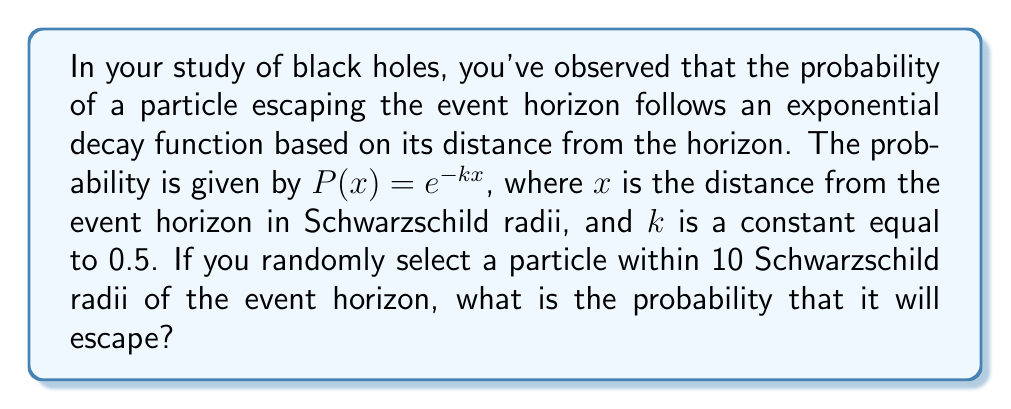What is the answer to this math problem? To solve this problem, we need to integrate the probability density function over the given range and normalize it. Here's the step-by-step solution:

1) The probability density function is given by $P(x) = e^{-kx}$ where $k = 0.5$.

2) To find the probability of escape within 10 Schwarzschild radii, we need to integrate this function from 0 to 10:

   $$\int_0^{10} e^{-0.5x} dx$$

3) The integral of $e^{-ax}$ is $-\frac{1}{a}e^{-ax} + C$. In our case, $a = 0.5$.

4) Applying the limits:

   $$[-2e^{-0.5x}]_0^{10} = -2e^{-5} - (-2) = 2 - 2e^{-5}$$

5) To normalize this probability, we need to divide by the total probability over all possible distances (from 0 to infinity):

   $$\int_0^{\infty} e^{-0.5x} dx = [-2e^{-0.5x}]_0^{\infty} = 0 - (-2) = 2$$

6) Therefore, the normalized probability is:

   $$P(\text{escape}) = \frac{2 - 2e^{-5}}{2} = 1 - e^{-5}$$

7) Calculate the final value:

   $$1 - e^{-5} \approx 0.9933$$
Answer: $1 - e^{-5} \approx 0.9933$ 